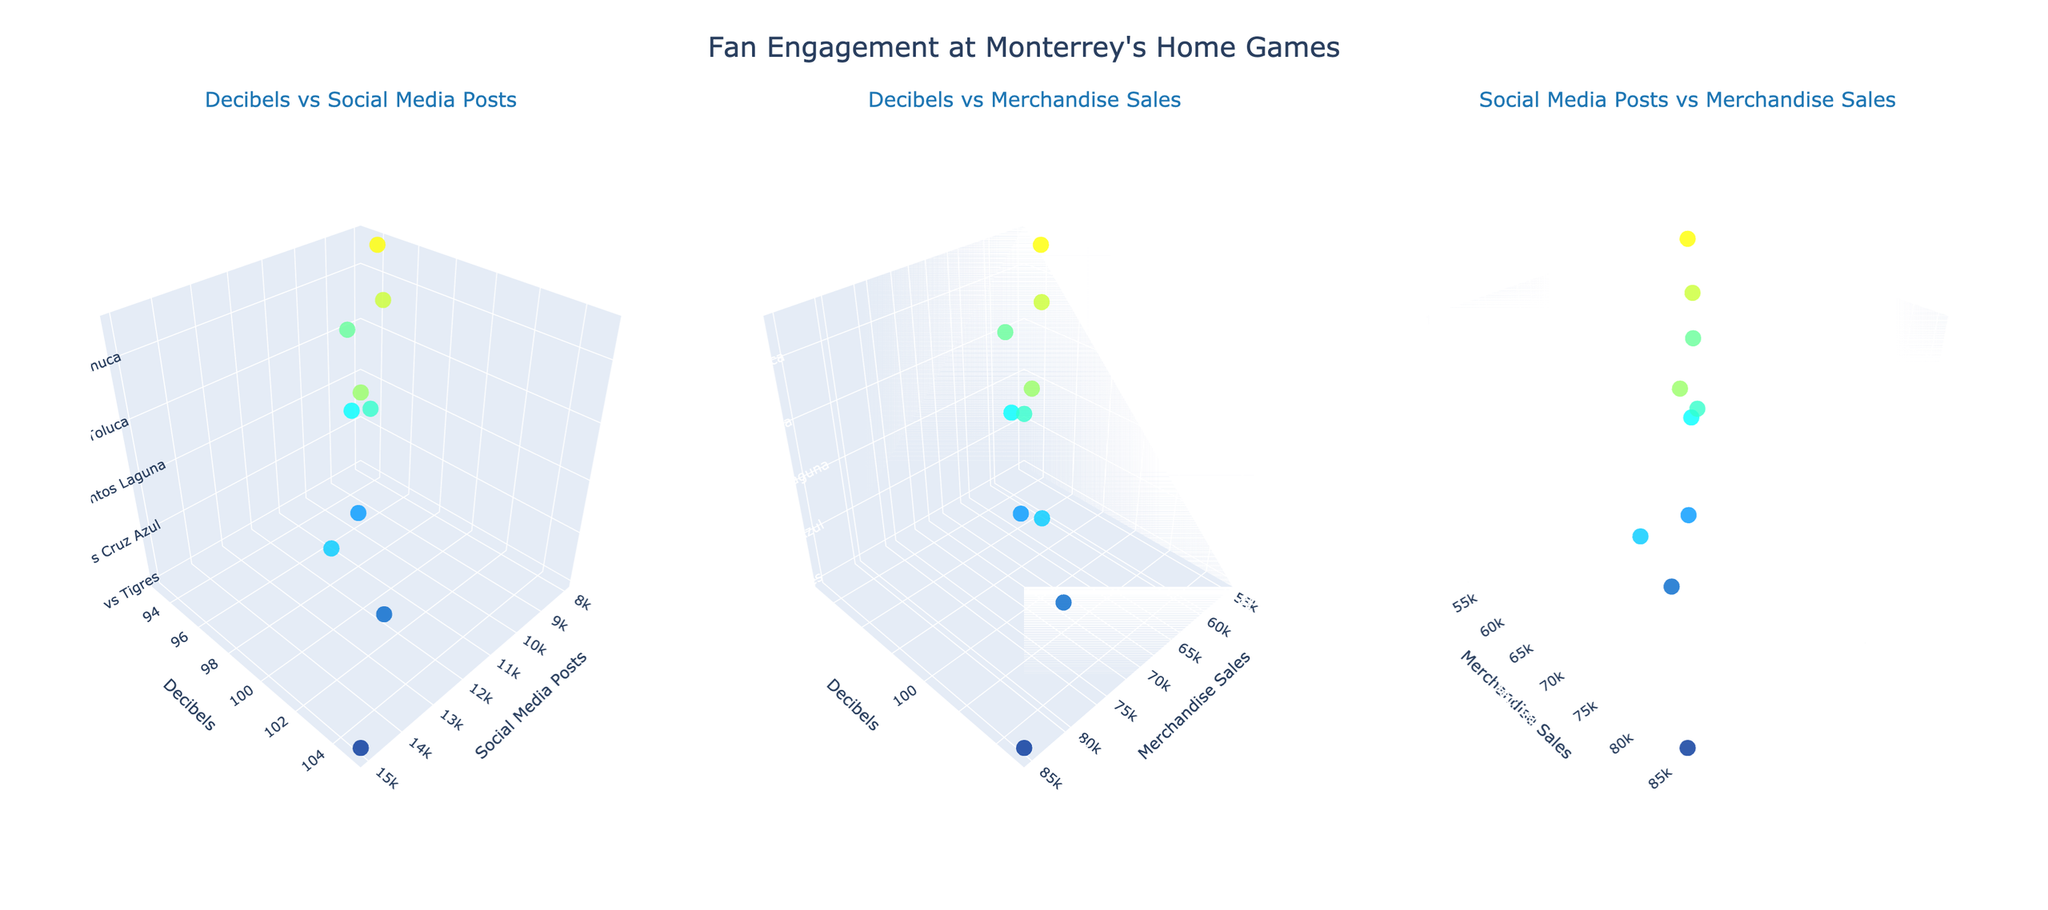what is the highest decibel level recorded? By looking at the first subplot "Decibels vs Social Media Posts," we can observe the highest point on the decibels axis. The highest decibel level recorded is for the match vs Tigres.
Answer: 105 IN the subplot "Decibels vs Merchandise Sales," which match had the lowest merchandise sales? We can see the match that appears at the lowest point in the Merchandise Sales axis while tracking the decibels level. The match vs Atlas had the lowest merchandise sales.
Answer: Atlas Which match had the highest number of social_media_posts? By checking the extremes on the Social Media Posts axis in the first and third subplots, we find that the match vs Tigres had the highest number of Social Media Posts.
Answer: vs Tigres How does the decibel level for the match vs America compare to the match vs Chivas? By observing the positions on the decibels axis in both subplots involving decibels, we see that the match vs America had a decibel level of 102, which is slightly higher than the match vs Chivas with a decibel level of 100.
Answer: America had higher decibel levels than Chivas What is the average decibel level across all matches? Sum the decibel levels (105 + 102 + 98 + 100 + 95 + 97 + 93 + 99 + 96 + 94) = 979. The average is 979 divided by 10 matches, resulting in an average decibel level of 97.9.
Answer: 97.9 Among the matches with merchandise sales greater than 70,000, which one had the highest decibels? First, identify matches with merchandise sales higher than 70,000, which are Tigres (85,000), America (72,000), and Cruz Azul (68,000). Out of these matches, the match vs Tigres has the highest decibels at 105.
Answer: vs Tigres Is there a positive correlation between social media posts and decibel levels? By looking at the scatter pattern in the "Decibels vs Social Media Posts" subplot, we observe that as the decibels increase, the number of social media posts also tends to be higher.
Answer: Yes Is the match vs Pachuca better in terms of merchandise sales or social media posts? Compare the positions on the relevant axes in the respective subplots. The match vs Pachuca had higher merchandise sales (60,000) than it had social media posts (9,000).
Answer: Merchandise Sales Which match had the least social media activity but was among the highest in merchandise sales? First, find the match with the least social media posts (vs Atlas, 8,000). Then, verify it against merchandise sales. The match with the least social media posts is also among the lowest in merchandise sales, not the highest. So, reconsider the second least, which is Santos Laguna with 9,500 social media posts having high merchandise sales of 62,000.
Answer: Santos Laguna 